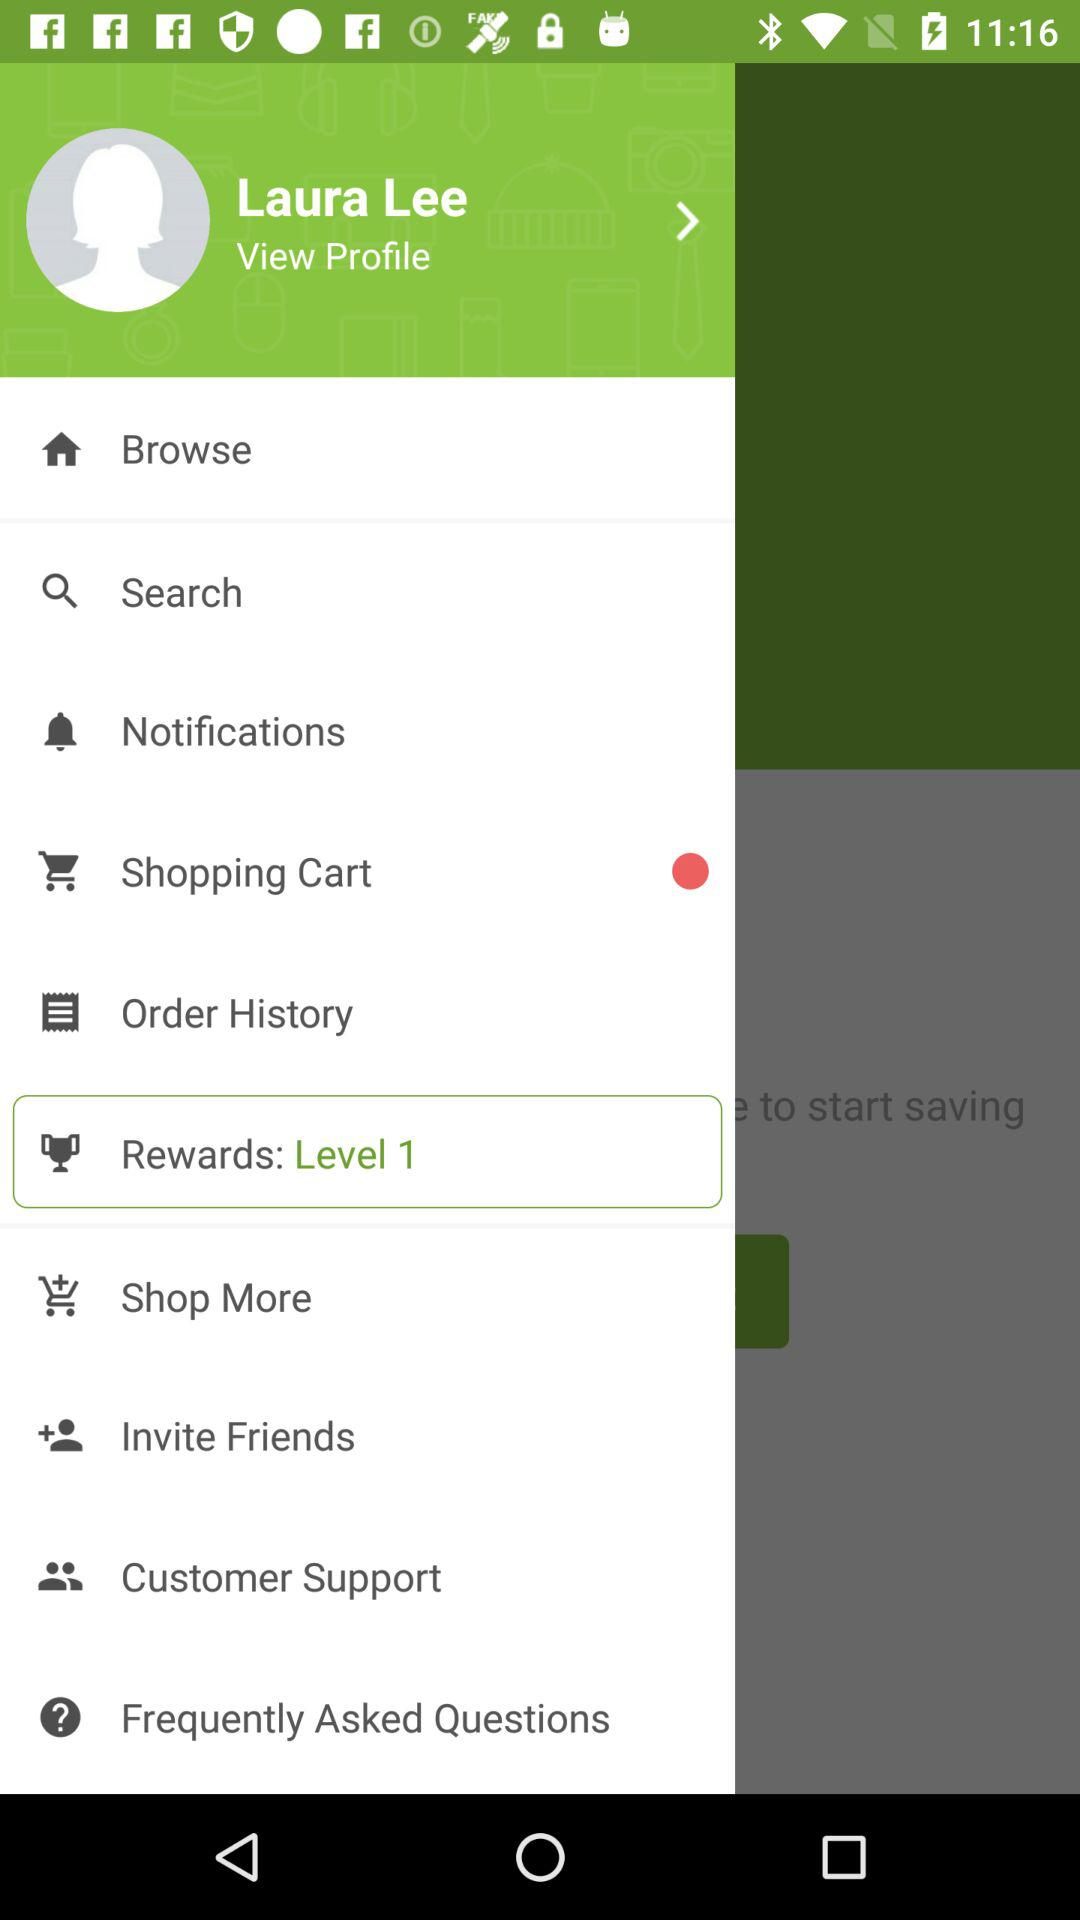What is the name of the user? The name of the user is Laura Lee. 